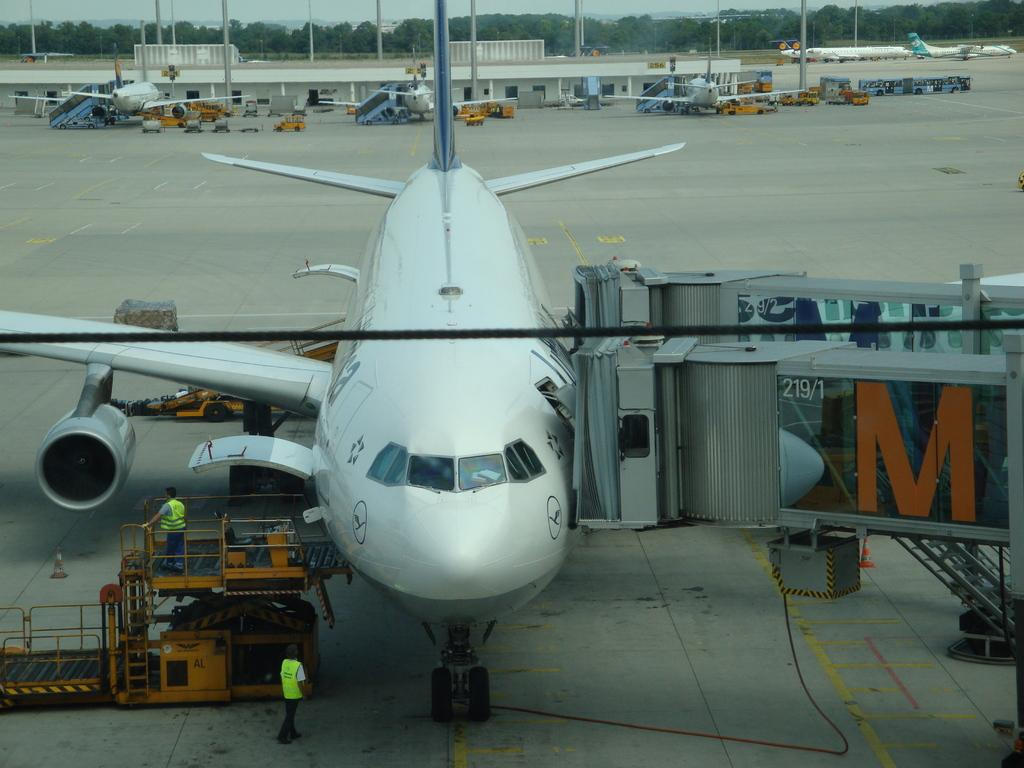What is the main subject of the image? The main subject of the image is planes. What else can be seen in the image besides the planes? There are vehicles on the road, two persons, a building, poles, trees, and the sky visible in the background. How many babies are playing in the sink in the image? There are no babies or sinks present in the image. 